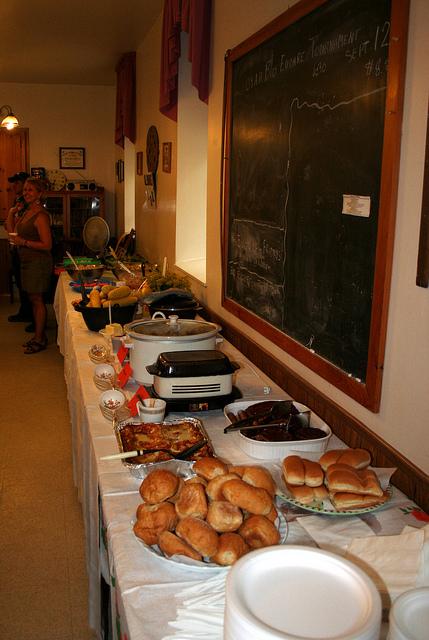What is the topping on the donuts?
Keep it brief. Sugar. What are the brown items on the plate?
Short answer required. Rolls. How many lights do you see on the ceiling?
Be succinct. 1. What is on the wall above the food?
Be succinct. Chalkboard. Is this a buffet?
Short answer required. Yes. What color are the plates?
Answer briefly. White. 